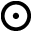<formula> <loc_0><loc_0><loc_500><loc_500>\odot</formula> 